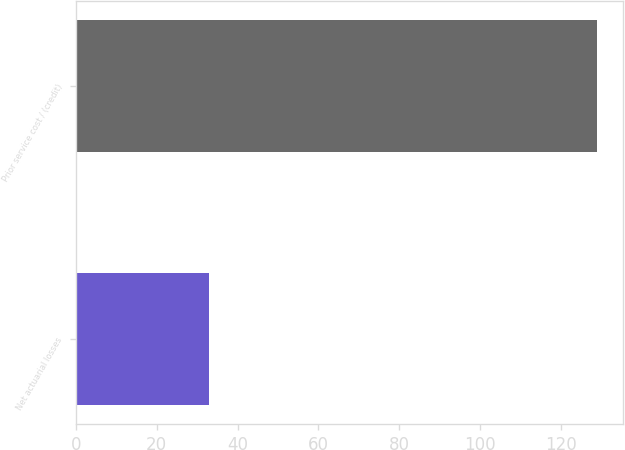<chart> <loc_0><loc_0><loc_500><loc_500><bar_chart><fcel>Net actuarial losses<fcel>Prior service cost / (credit)<nl><fcel>33<fcel>129<nl></chart> 